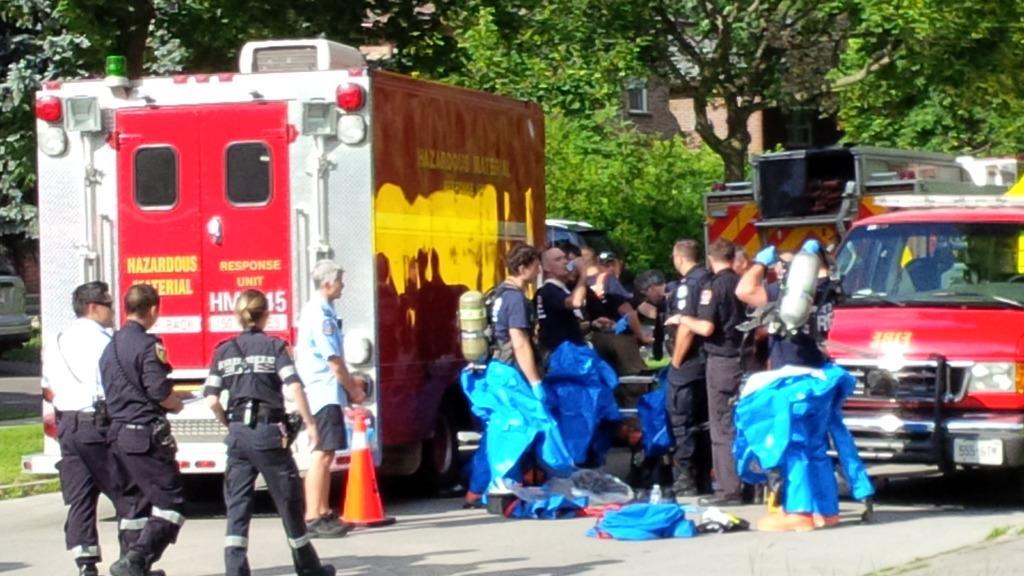Can you describe this image briefly? In the center of the image there are people standing on the road. There is a fire extinguisher van. In the background of the image there are trees. To the left side of the image there is grass. There are buildings. 